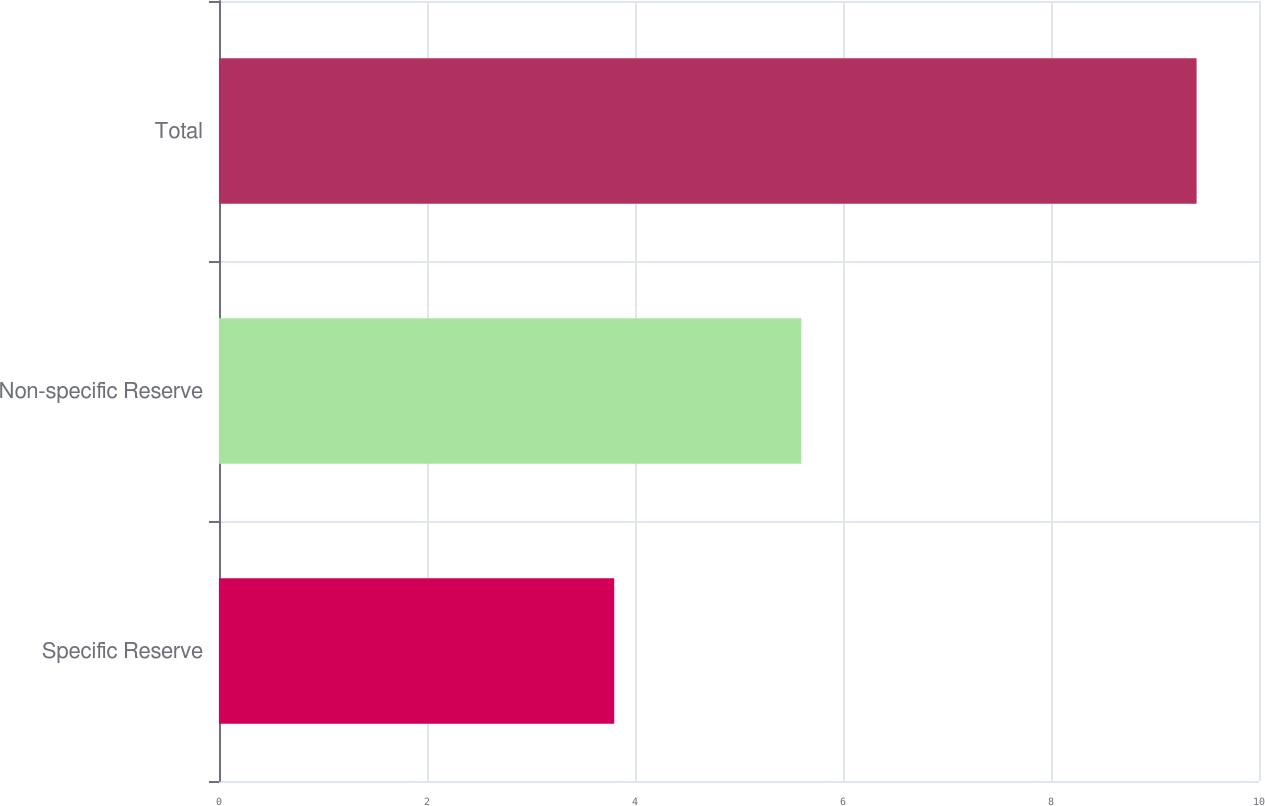Convert chart. <chart><loc_0><loc_0><loc_500><loc_500><bar_chart><fcel>Specific Reserve<fcel>Non-specific Reserve<fcel>Total<nl><fcel>3.8<fcel>5.6<fcel>9.4<nl></chart> 